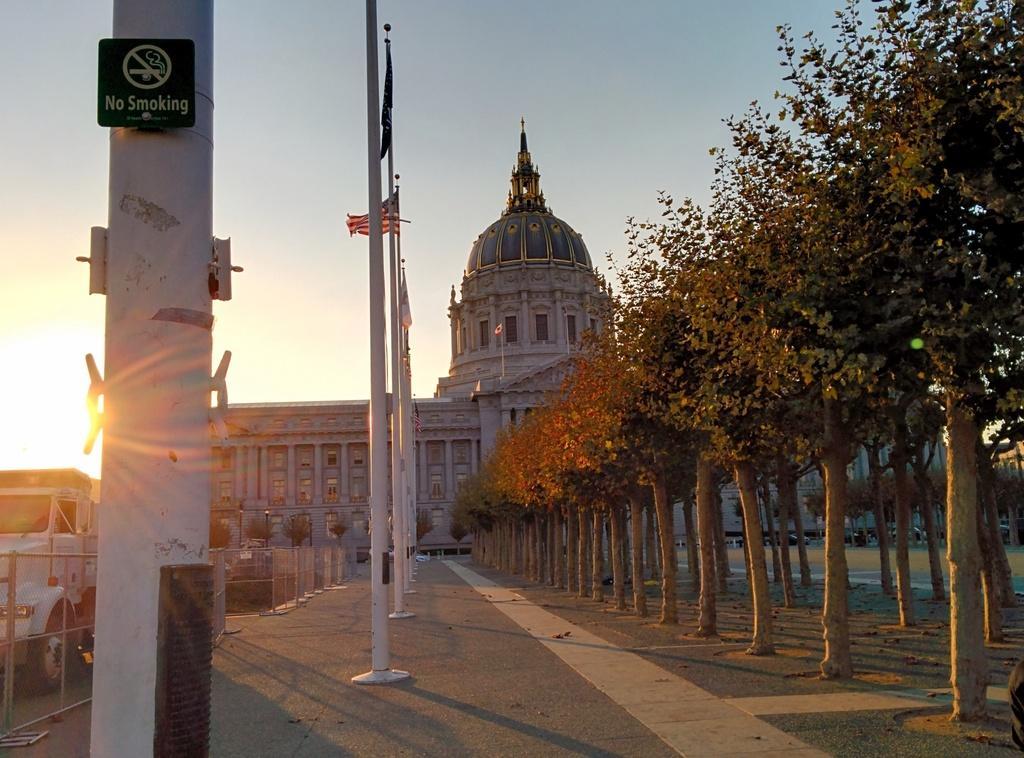In one or two sentences, can you explain what this image depicts? In the picture we can see some poles and beside it, we can see some trees and behind it, we can see the palace and beside the poles we can see a part of the truck, which is white in color and in the background we can see the sky with a sunshine. 